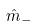Convert formula to latex. <formula><loc_0><loc_0><loc_500><loc_500>\hat { m } _ { - }</formula> 